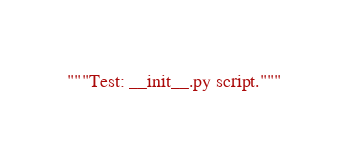<code> <loc_0><loc_0><loc_500><loc_500><_Python_>"""Test: __init__.py script."""
</code> 